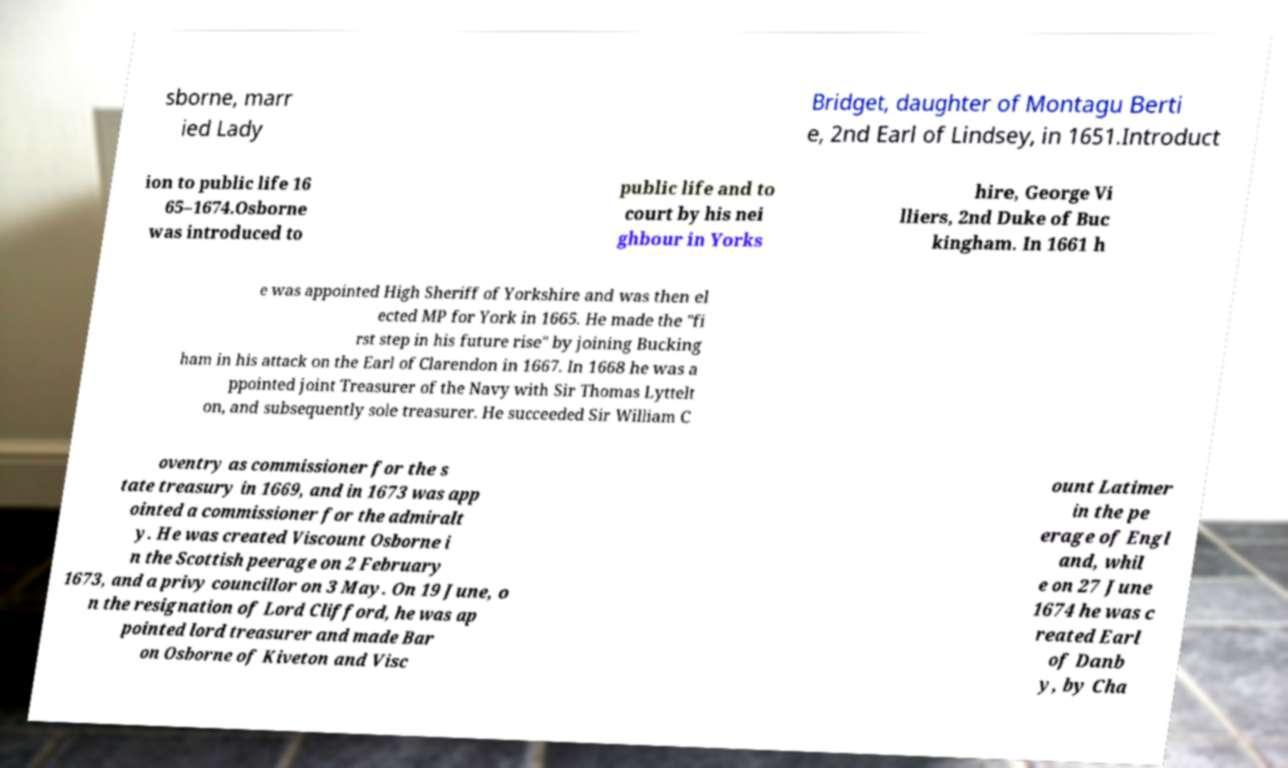What messages or text are displayed in this image? I need them in a readable, typed format. sborne, marr ied Lady Bridget, daughter of Montagu Berti e, 2nd Earl of Lindsey, in 1651.Introduct ion to public life 16 65–1674.Osborne was introduced to public life and to court by his nei ghbour in Yorks hire, George Vi lliers, 2nd Duke of Buc kingham. In 1661 h e was appointed High Sheriff of Yorkshire and was then el ected MP for York in 1665. He made the "fi rst step in his future rise" by joining Bucking ham in his attack on the Earl of Clarendon in 1667. In 1668 he was a ppointed joint Treasurer of the Navy with Sir Thomas Lyttelt on, and subsequently sole treasurer. He succeeded Sir William C oventry as commissioner for the s tate treasury in 1669, and in 1673 was app ointed a commissioner for the admiralt y. He was created Viscount Osborne i n the Scottish peerage on 2 February 1673, and a privy councillor on 3 May. On 19 June, o n the resignation of Lord Clifford, he was ap pointed lord treasurer and made Bar on Osborne of Kiveton and Visc ount Latimer in the pe erage of Engl and, whil e on 27 June 1674 he was c reated Earl of Danb y, by Cha 